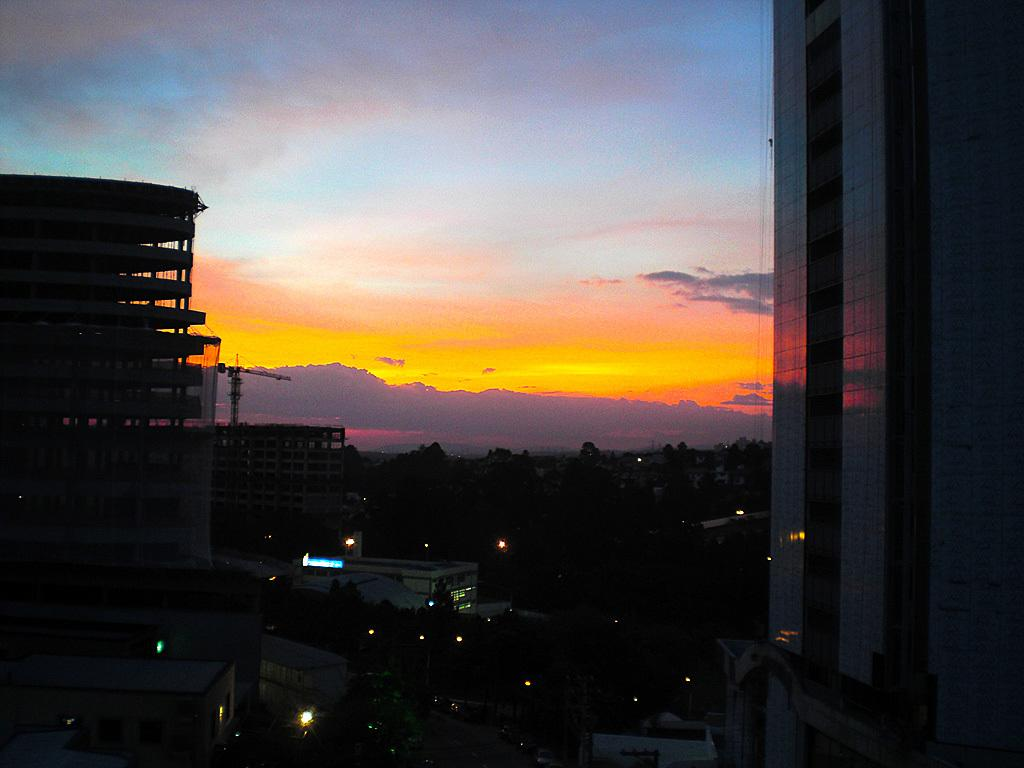What type of structures can be seen in the image? There are buildings in the image. Are there any visible sources of illumination in the image? Yes, there are lights visible in the image. How would you describe the colors of the sky in the background? The sky in the background has orange, blue, and white colors. Can you see any actors performing in a hall in the image? There is no hall or actors present in the image. Are there any cobwebs visible in the image? There are no cobwebs present in the image. 